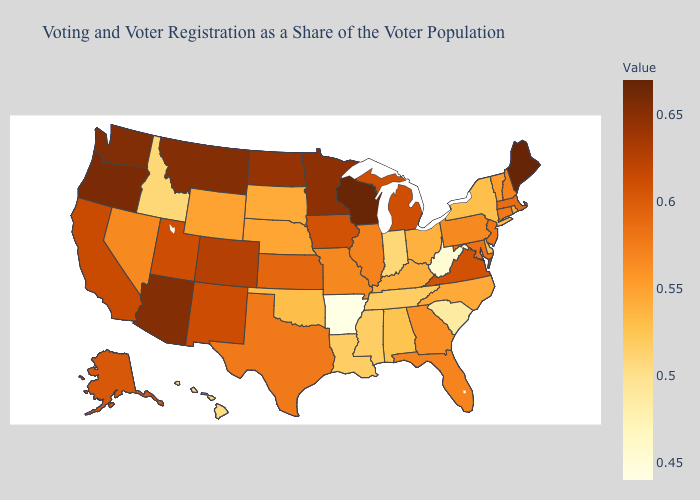Does Arkansas have the lowest value in the USA?
Quick response, please. Yes. Which states have the highest value in the USA?
Keep it brief. Maine. Does Ohio have the highest value in the MidWest?
Concise answer only. No. Among the states that border Texas , does Arkansas have the highest value?
Write a very short answer. No. Among the states that border Ohio , which have the highest value?
Keep it brief. Michigan. 